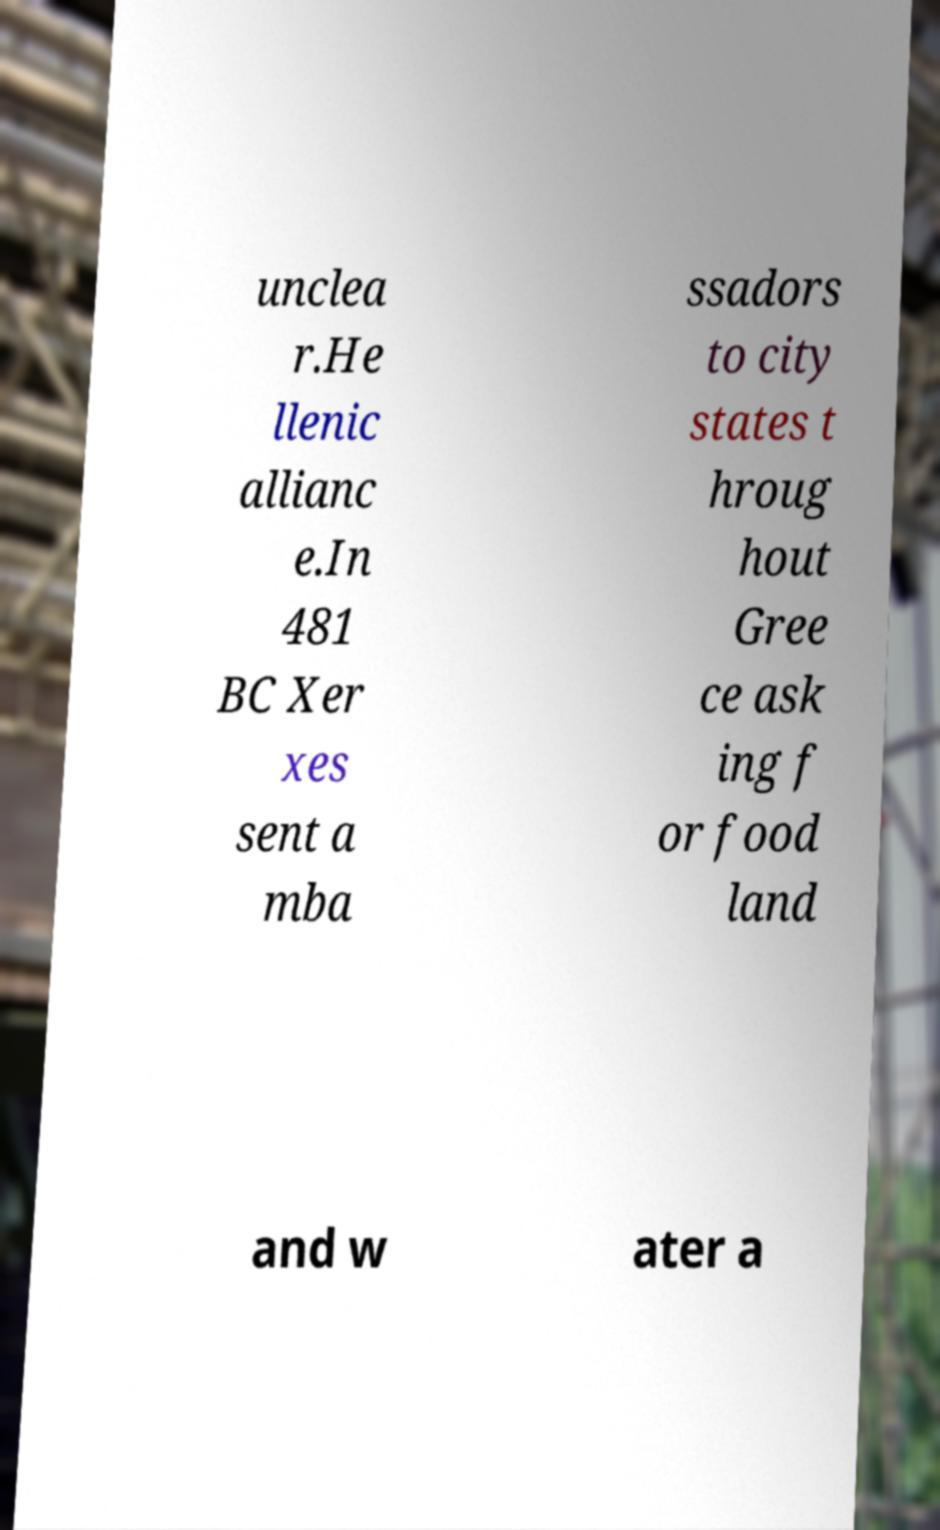I need the written content from this picture converted into text. Can you do that? unclea r.He llenic allianc e.In 481 BC Xer xes sent a mba ssadors to city states t hroug hout Gree ce ask ing f or food land and w ater a 